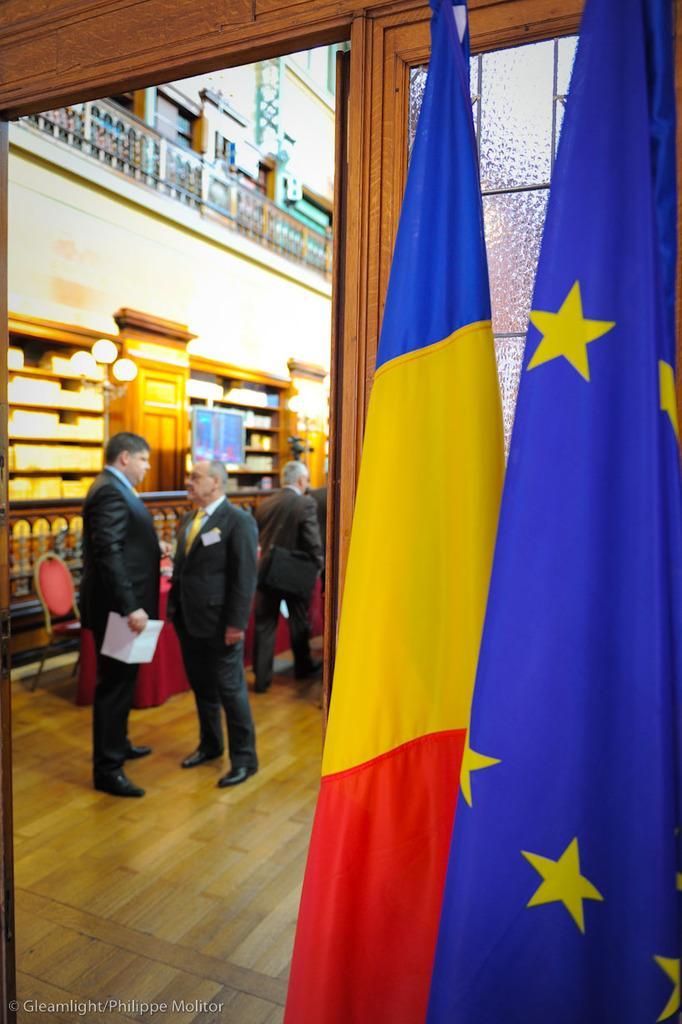Describe this image in one or two sentences. In this image we can see a blue color and yellow and red color flags and we can see the glass windows. In the background, we can see these people are standing on the wooden floor, we can see chair, table and wooden wall. 